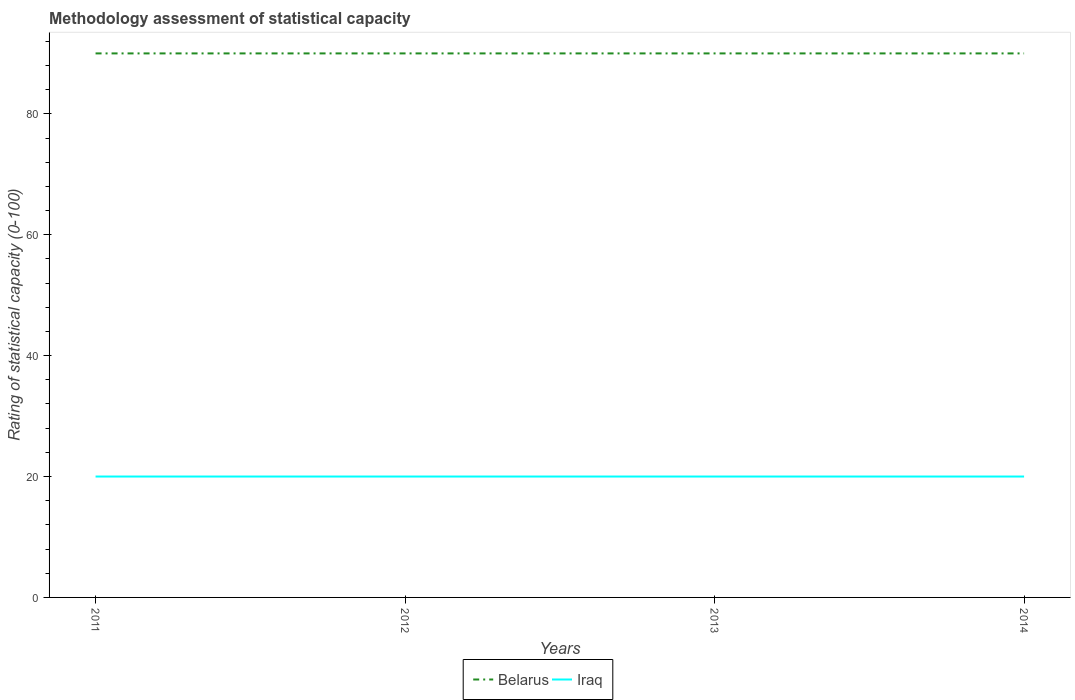Does the line corresponding to Iraq intersect with the line corresponding to Belarus?
Make the answer very short. No. Is the number of lines equal to the number of legend labels?
Offer a very short reply. Yes. Across all years, what is the maximum rating of statistical capacity in Iraq?
Keep it short and to the point. 20. In which year was the rating of statistical capacity in Iraq maximum?
Make the answer very short. 2011. What is the total rating of statistical capacity in Iraq in the graph?
Offer a terse response. 0. What is the difference between the highest and the lowest rating of statistical capacity in Belarus?
Provide a succinct answer. 0. Is the rating of statistical capacity in Iraq strictly greater than the rating of statistical capacity in Belarus over the years?
Ensure brevity in your answer.  Yes. How many years are there in the graph?
Keep it short and to the point. 4. Does the graph contain any zero values?
Your answer should be very brief. No. What is the title of the graph?
Ensure brevity in your answer.  Methodology assessment of statistical capacity. Does "Mozambique" appear as one of the legend labels in the graph?
Provide a short and direct response. No. What is the label or title of the Y-axis?
Give a very brief answer. Rating of statistical capacity (0-100). What is the Rating of statistical capacity (0-100) in Iraq in 2011?
Provide a short and direct response. 20. What is the Rating of statistical capacity (0-100) in Iraq in 2012?
Offer a terse response. 20. What is the Rating of statistical capacity (0-100) in Belarus in 2013?
Provide a short and direct response. 90. What is the Rating of statistical capacity (0-100) of Iraq in 2013?
Ensure brevity in your answer.  20. Across all years, what is the maximum Rating of statistical capacity (0-100) in Belarus?
Provide a short and direct response. 90. Across all years, what is the minimum Rating of statistical capacity (0-100) of Iraq?
Give a very brief answer. 20. What is the total Rating of statistical capacity (0-100) in Belarus in the graph?
Make the answer very short. 360. What is the difference between the Rating of statistical capacity (0-100) of Iraq in 2011 and that in 2012?
Your answer should be compact. 0. What is the difference between the Rating of statistical capacity (0-100) of Iraq in 2011 and that in 2014?
Offer a terse response. 0. What is the difference between the Rating of statistical capacity (0-100) of Iraq in 2012 and that in 2013?
Offer a very short reply. 0. What is the difference between the Rating of statistical capacity (0-100) in Iraq in 2012 and that in 2014?
Provide a short and direct response. 0. What is the difference between the Rating of statistical capacity (0-100) of Iraq in 2013 and that in 2014?
Your answer should be very brief. 0. What is the difference between the Rating of statistical capacity (0-100) in Belarus in 2011 and the Rating of statistical capacity (0-100) in Iraq in 2013?
Ensure brevity in your answer.  70. What is the difference between the Rating of statistical capacity (0-100) in Belarus in 2011 and the Rating of statistical capacity (0-100) in Iraq in 2014?
Offer a very short reply. 70. What is the difference between the Rating of statistical capacity (0-100) of Belarus in 2012 and the Rating of statistical capacity (0-100) of Iraq in 2013?
Keep it short and to the point. 70. What is the difference between the Rating of statistical capacity (0-100) of Belarus in 2013 and the Rating of statistical capacity (0-100) of Iraq in 2014?
Ensure brevity in your answer.  70. In the year 2013, what is the difference between the Rating of statistical capacity (0-100) of Belarus and Rating of statistical capacity (0-100) of Iraq?
Your answer should be compact. 70. What is the ratio of the Rating of statistical capacity (0-100) of Iraq in 2011 to that in 2012?
Your response must be concise. 1. What is the ratio of the Rating of statistical capacity (0-100) of Iraq in 2011 to that in 2013?
Provide a short and direct response. 1. What is the ratio of the Rating of statistical capacity (0-100) of Iraq in 2011 to that in 2014?
Your answer should be compact. 1. What is the ratio of the Rating of statistical capacity (0-100) of Iraq in 2012 to that in 2013?
Your answer should be very brief. 1. What is the ratio of the Rating of statistical capacity (0-100) in Belarus in 2012 to that in 2014?
Provide a succinct answer. 1. What is the ratio of the Rating of statistical capacity (0-100) of Iraq in 2012 to that in 2014?
Make the answer very short. 1. What is the ratio of the Rating of statistical capacity (0-100) of Iraq in 2013 to that in 2014?
Ensure brevity in your answer.  1. What is the difference between the highest and the second highest Rating of statistical capacity (0-100) of Belarus?
Make the answer very short. 0. What is the difference between the highest and the second highest Rating of statistical capacity (0-100) of Iraq?
Provide a succinct answer. 0. 